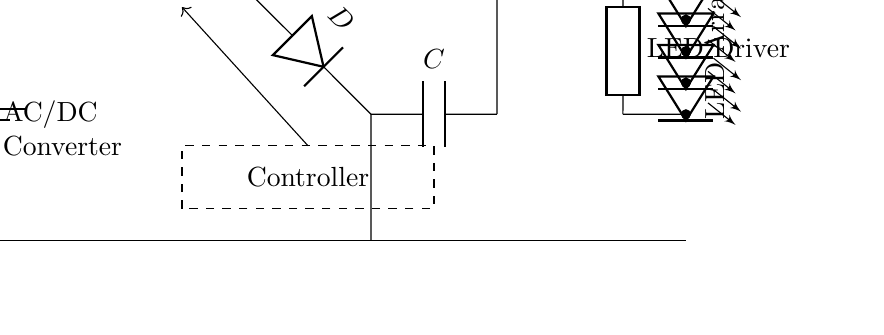What is the input voltage of the circuit? The circuit shows a battery symbol labeled as V_in at the input, indicating the input voltage is supplied from a battery source.
Answer: V_in What components are included in the buck converter section? The buck converter section consists of a switch, a diode, and an inductor. These components work together to reduce the input voltage efficiently.
Answer: Switch, diode, inductor How many LEDs are in the LED array? The LED array contains four LEDs arranged in series, as indicated by the four LED symbols connected end-to-end.
Answer: Four What is the purpose of the capacitor in this circuit? The capacitor is used for filtering and smoothing the output voltage from the buck converter, ensuring stable voltage supply to the LED driver and LED array.
Answer: Filtering and smoothing What does the controller do in this circuit? The controller manages the operation of the buck converter, adjusting the switch to control the output voltage to the LED driver for optimal performance.
Answer: Manages buck converter operation What type of converter is shown in this circuit? The circuit features a buck converter, as evident from the labeled section and components that step down voltage efficiently.
Answer: Buck converter What type of load is primarily powered by this circuit? The primary load powered by this circuit is the LED array, highlighted in the diagram as the component that receives the controlled output voltage.
Answer: LED array 